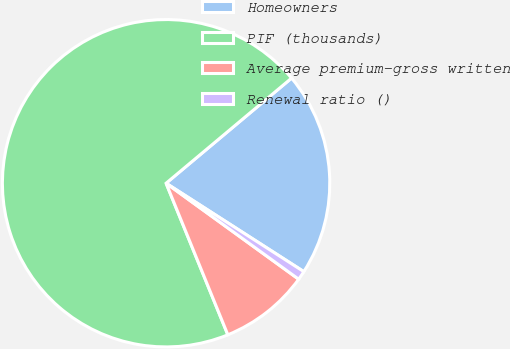Convert chart to OTSL. <chart><loc_0><loc_0><loc_500><loc_500><pie_chart><fcel>Homeowners<fcel>PIF (thousands)<fcel>Average premium-gross written<fcel>Renewal ratio ()<nl><fcel>20.18%<fcel>70.06%<fcel>8.87%<fcel>0.89%<nl></chart> 